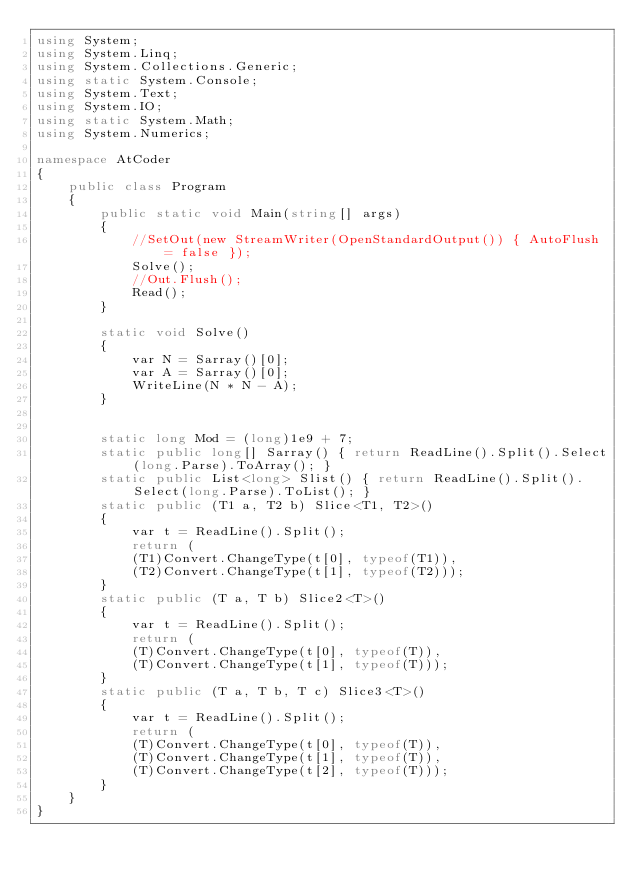Convert code to text. <code><loc_0><loc_0><loc_500><loc_500><_C#_>using System;
using System.Linq;
using System.Collections.Generic;
using static System.Console;
using System.Text;
using System.IO;
using static System.Math;
using System.Numerics;

namespace AtCoder
{
    public class Program
    {
        public static void Main(string[] args)
        {
            //SetOut(new StreamWriter(OpenStandardOutput()) { AutoFlush = false });
            Solve();
            //Out.Flush();
            Read();
        }

        static void Solve()
        {
            var N = Sarray()[0];
            var A = Sarray()[0];
            WriteLine(N * N - A);
        }


        static long Mod = (long)1e9 + 7;
        static public long[] Sarray() { return ReadLine().Split().Select(long.Parse).ToArray(); }
        static public List<long> Slist() { return ReadLine().Split().Select(long.Parse).ToList(); }
        static public (T1 a, T2 b) Slice<T1, T2>()
        {
            var t = ReadLine().Split();
            return (
            (T1)Convert.ChangeType(t[0], typeof(T1)),
            (T2)Convert.ChangeType(t[1], typeof(T2)));
        }
        static public (T a, T b) Slice2<T>()
        {
            var t = ReadLine().Split();
            return (
            (T)Convert.ChangeType(t[0], typeof(T)),
            (T)Convert.ChangeType(t[1], typeof(T)));
        }
        static public (T a, T b, T c) Slice3<T>()
        {
            var t = ReadLine().Split();
            return (
            (T)Convert.ChangeType(t[0], typeof(T)),
            (T)Convert.ChangeType(t[1], typeof(T)),
            (T)Convert.ChangeType(t[2], typeof(T)));
        }
    }
}</code> 